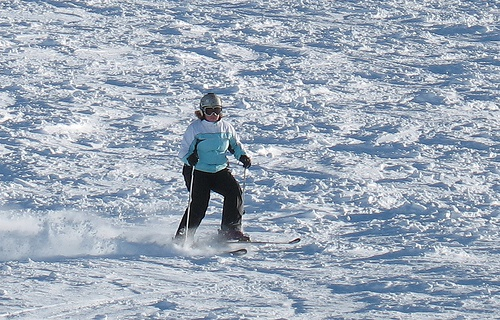Describe the objects in this image and their specific colors. I can see people in lightgray, black, gray, and darkgray tones and skis in lightgray, darkgray, and gray tones in this image. 